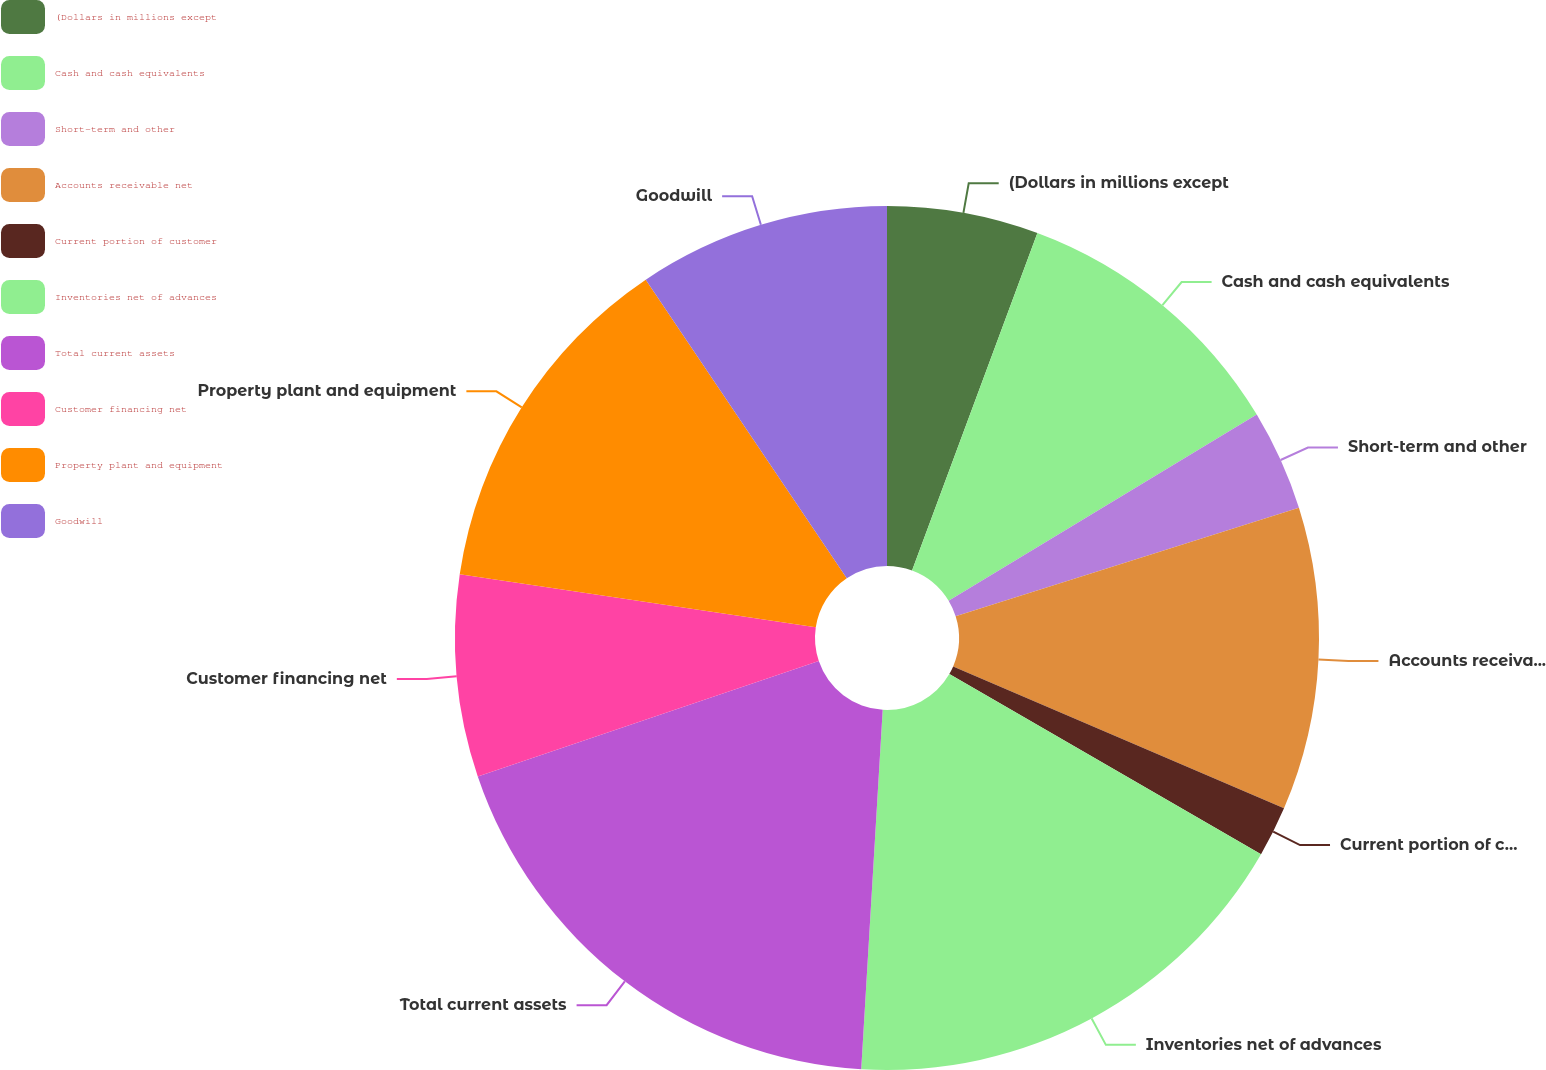Convert chart to OTSL. <chart><loc_0><loc_0><loc_500><loc_500><pie_chart><fcel>(Dollars in millions except<fcel>Cash and cash equivalents<fcel>Short-term and other<fcel>Accounts receivable net<fcel>Current portion of customer<fcel>Inventories net of advances<fcel>Total current assets<fcel>Customer financing net<fcel>Property plant and equipment<fcel>Goodwill<nl><fcel>5.66%<fcel>10.69%<fcel>3.78%<fcel>11.32%<fcel>1.89%<fcel>17.61%<fcel>18.86%<fcel>7.55%<fcel>13.21%<fcel>9.43%<nl></chart> 